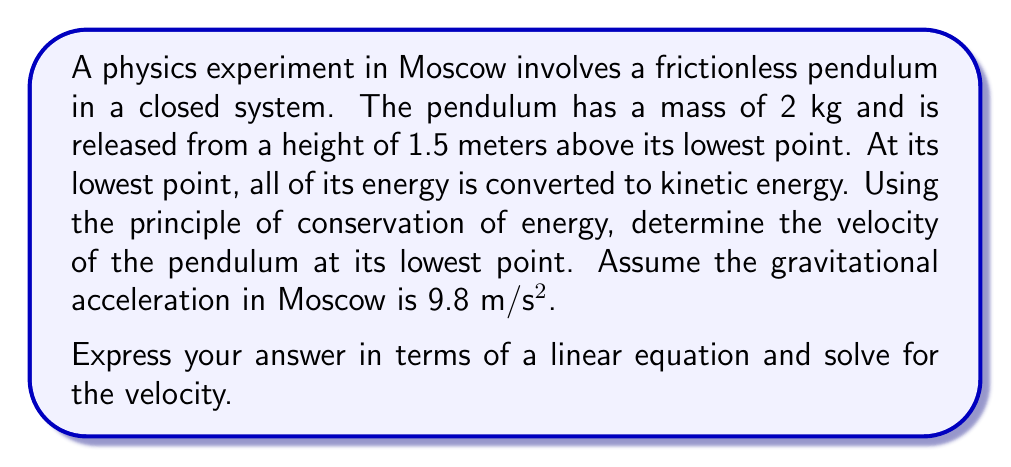Provide a solution to this math problem. Let's approach this step-by-step using the principle of conservation of energy:

1) In a closed system, the total energy remains constant. In this case, the initial potential energy will be converted to kinetic energy at the lowest point.

2) The initial potential energy is given by:
   $$PE = mgh$$
   where $m$ is mass, $g$ is gravitational acceleration, and $h$ is height.

3) The kinetic energy at the lowest point is given by:
   $$KE = \frac{1}{2}mv^2$$
   where $v$ is velocity.

4) According to the conservation of energy:
   $$PE_{initial} = KE_{final}$$

5) Substituting the formulas:
   $$mgh = \frac{1}{2}mv^2$$

6) Now, let's plug in the known values:
   $$(2 \text{ kg})(9.8 \text{ m/s²})(1.5 \text{ m}) = \frac{1}{2}(2 \text{ kg})v^2$$

7) Simplify:
   $$29.4 = v^2$$

8) To solve for $v$, we take the square root of both sides:
   $$v = \sqrt{29.4} = 5.42 \text{ m/s}$$

This problem demonstrates how linear equations can be used to model and solve problems related to energy conservation in a closed system. The equation $mgh = \frac{1}{2}mv^2$ is linear in terms of $v^2$, allowing us to solve for the velocity directly.
Answer: The velocity of the pendulum at its lowest point is approximately 5.42 m/s. 